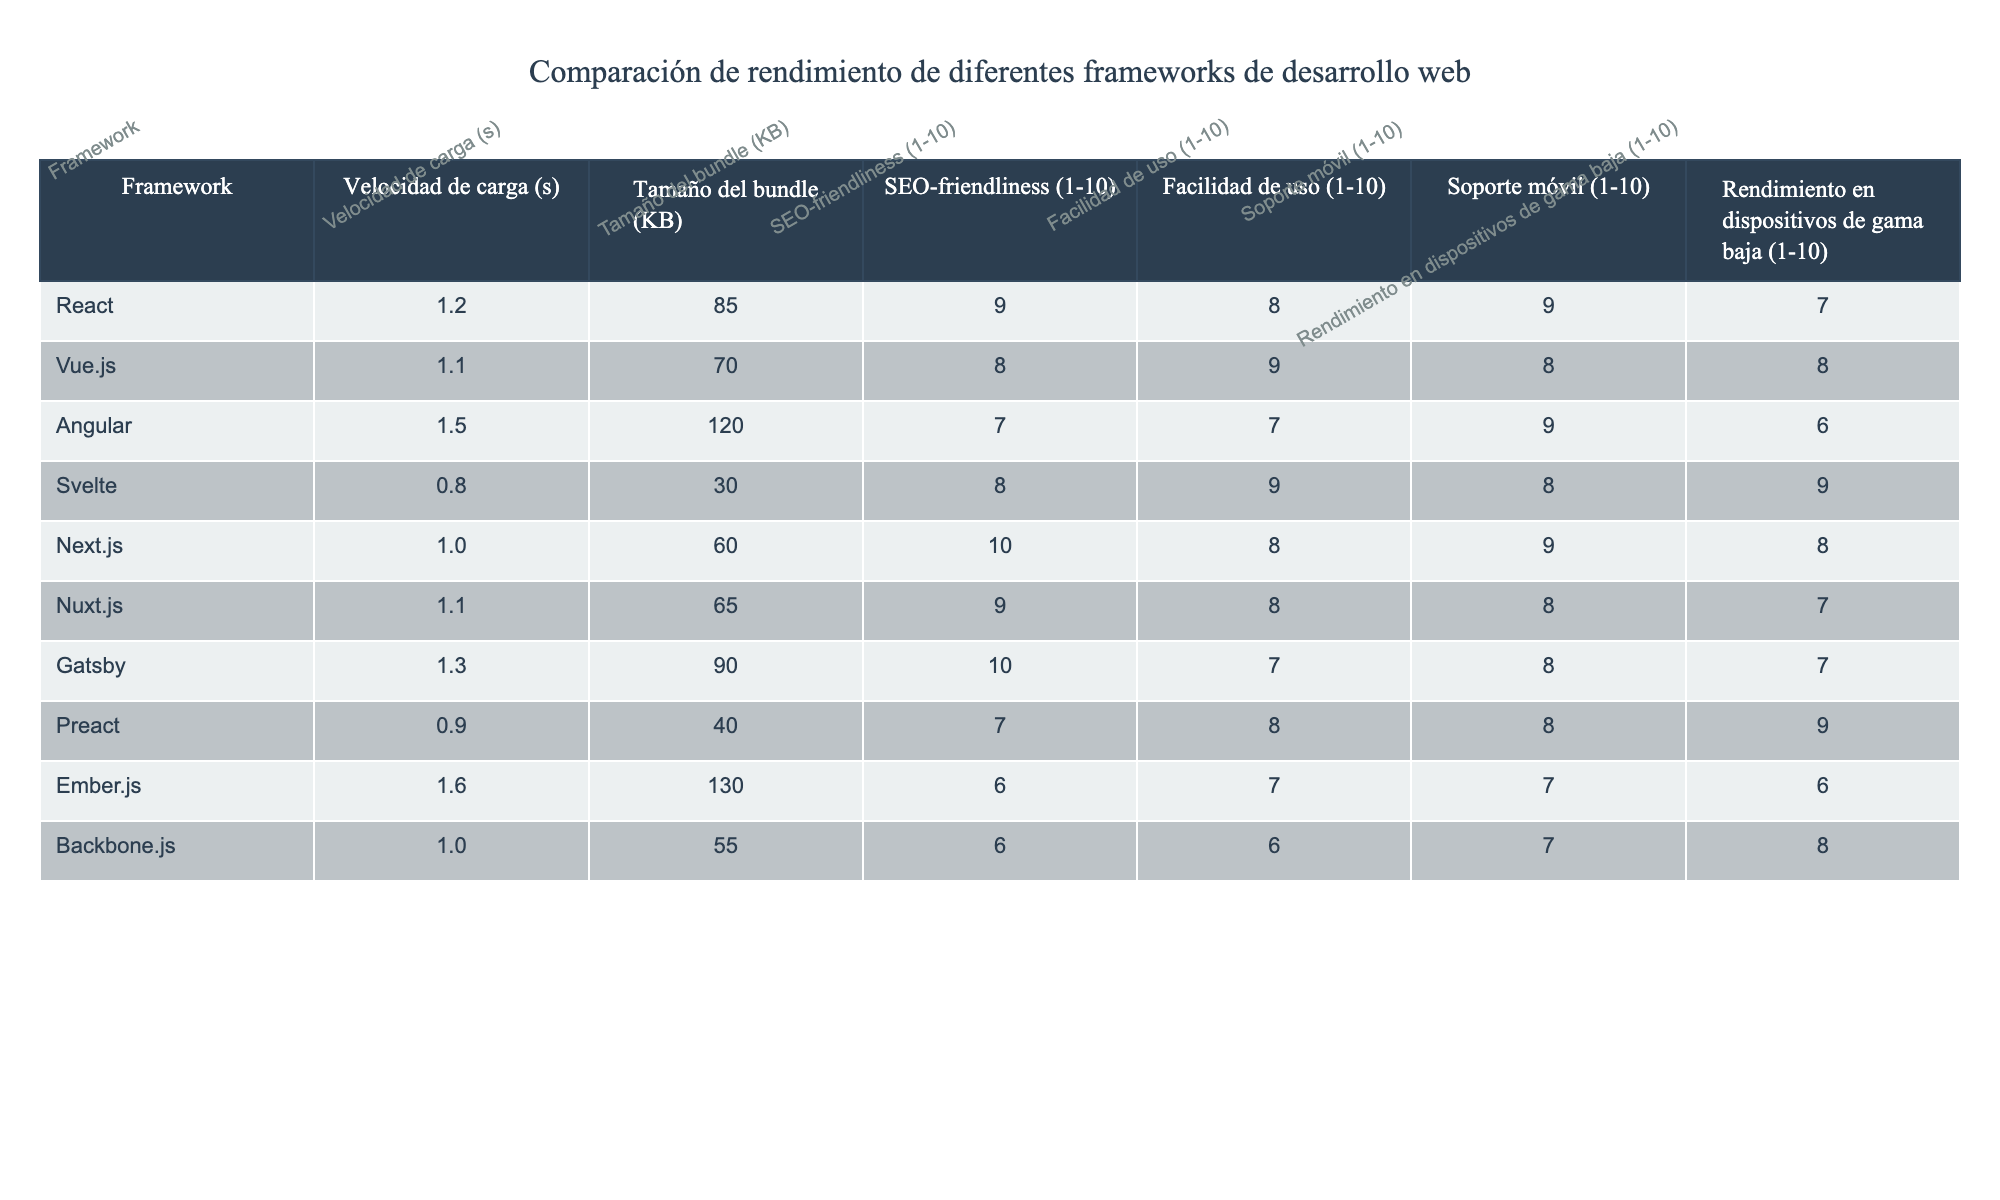¿Cuál es el framework con la mayor velocidad de carga? Al observar la tabla, el framework Svelte tiene la velocidad de carga más baja, con 0.8 segundos.
Answer: Svelte ¿Qué framework tiene el tamaño de bundle más pequeño? En la tabla, Svelte presenta el tamaño de bundle más pequeño, que es de 30 KB.
Answer: Svelte ¿Cuál es el SEO-friendliness promedio de los frameworks? Se suman los valores de SEO-friendliness (9 + 8 + 7 + 8 + 10 + 9 + 10 + 7 + 6 + 6 = 78) y se dividen por 10, lo que da un promedio de 7.8.
Answer: 7.8 ¿Es Angular más fácil de usar que React? Angular tiene una facilidad de uso de 7, mientras que React tiene 8, por lo tanto, Angular no es más fácil de usar.
Answer: No ¿Cuál es el rendimiento en dispositivos de gama baja del framework que tiene la mejor SEO-friendliness? Next.js tiene la mejor SEO-friendliness con 10, y su rendimiento en dispositivos de gama baja es 8.
Answer: 8 ¿Hay algún framework con una velocidad de carga menor a 1 segundo? Svelte y Preact tienen velocidades de carga de 0.8 y 0.9 segundos, respectivamente, que son menores a 1 segundo.
Answer: Sí ¿Qué framework tiene el mejor rendimiento en dispositivos de gama baja comparado con el resto? Svelte tiene el mejor rendimiento en dispositivos de gama baja con un valor de 9. Revisando todos los valores, 9 es el mayor.
Answer: Svelte Si se consideran la velocidad de carga y el tamaño del bundle, ¿cuál es el framework más rápido y ligero? Svelte tiene la velocidad de carga más baja (0.8s) y el tamaño de bundle más pequeño (30 KB), siendo el más rápido y ligero.
Answer: Svelte ¿Cuál es la diferencia en tamaño de bundle entre Angular y Vue.js? El tamaño de bundle de Angular es 120 KB y el de Vue.js es 70 KB. La diferencia es 120 - 70 = 50 KB.
Answer: 50 KB ¿El rendimiento en dispositivos de gama baja de Backbone.js es mejor que el de Ember.js? Backbone.js tiene un rendimiento de 8 y Ember.js de 6, por lo que el rendimiento de Backbone.js es mejor.
Answer: Sí 